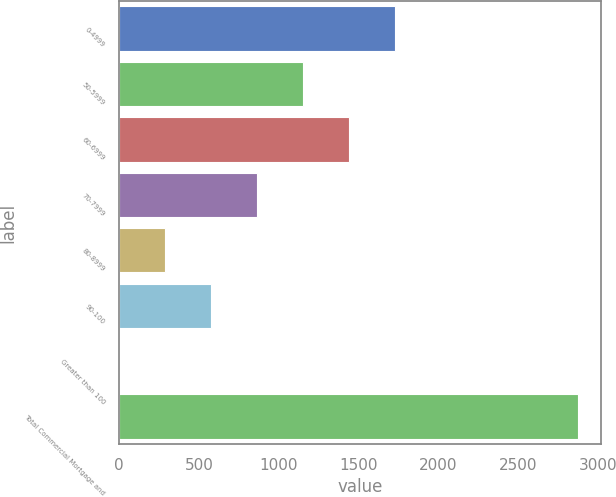Convert chart. <chart><loc_0><loc_0><loc_500><loc_500><bar_chart><fcel>0-4999<fcel>50-5999<fcel>60-6999<fcel>70-7999<fcel>80-8999<fcel>90-100<fcel>Greater than 100<fcel>Total Commercial Mortgage and<nl><fcel>1726.03<fcel>1151.03<fcel>1438.53<fcel>863.54<fcel>288.55<fcel>576.05<fcel>1.05<fcel>2876<nl></chart> 